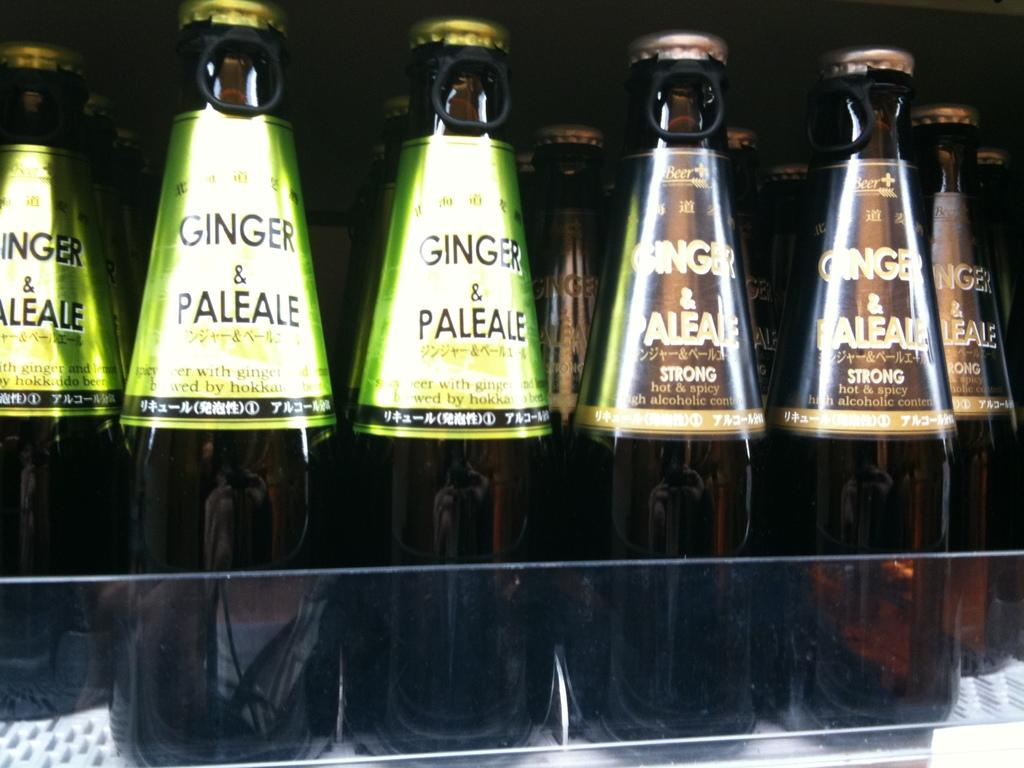Provide a one-sentence caption for the provided image. Bottles sitting on a shelf of Ginger and Paleale. 